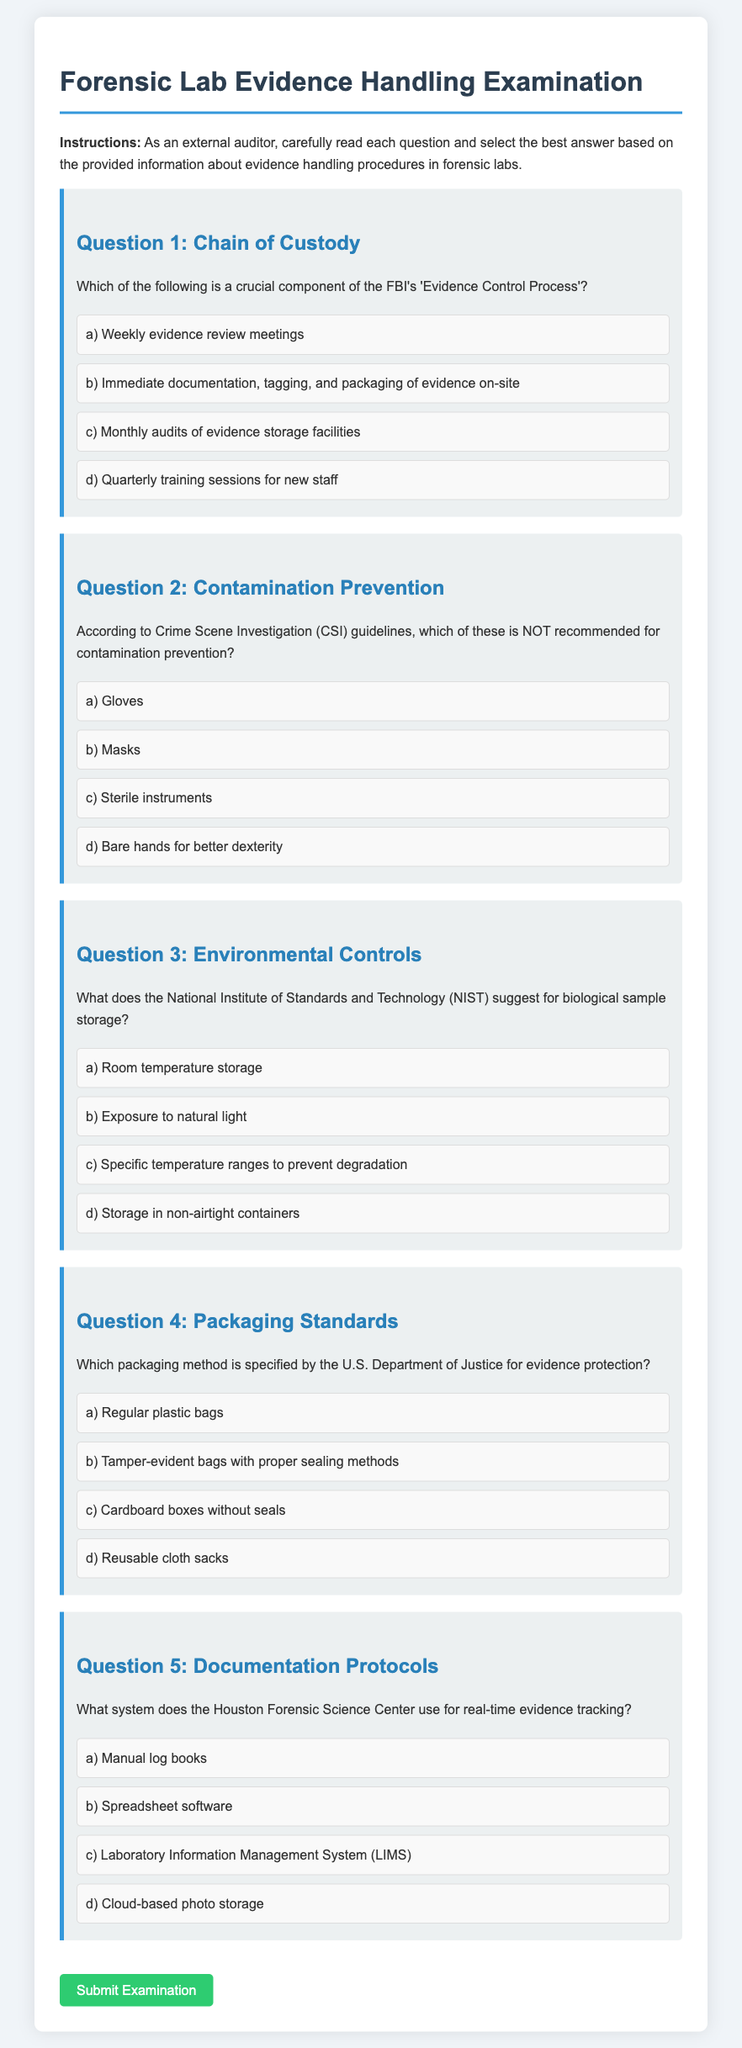What is the title of the document? The title of the document is prominently displayed at the top, indicating the focus of the content.
Answer: Forensic Lab Evidence Handling Examination What is the subject of Question 1 in the document? The subject of Question 1 is related to the FBI's protocols for evidence control, specifically about a crucial component of their process.
Answer: Chain of Custody According to the document, what is NOT recommended for contamination prevention? The document lists options for contamination prevention under Question 2 and highlights one that is not recommended.
Answer: Bare hands for better dexterity Which organization suggests specific temperature ranges for biological sample storage? The document mentions different organizations in relation to evidence handling, and one of them provides guidelines for biological sample storage.
Answer: National Institute of Standards and Technology What is the packaging method specified by the U.S. Department of Justice? The document specifically states a method for packaging that ensures evidence protection, answering the query about standards.
Answer: Tamper-evident bags with proper sealing methods What system is used by the Houston Forensic Science Center for evidence tracking? The document provides an option for evidence tracking used by a specific center, emphasizing the technology applied.
Answer: Laboratory Information Management System (LIMS) 